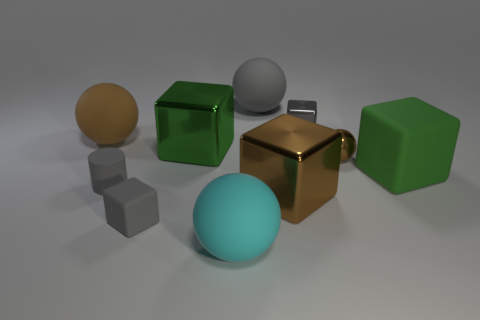The tiny matte object that is the same color as the rubber cylinder is what shape?
Make the answer very short. Cube. Does the small sphere have the same color as the cylinder?
Provide a succinct answer. No. What is the size of the cyan rubber object?
Keep it short and to the point. Large. There is a green object that is left of the large green block in front of the green metallic cube; how many tiny gray cylinders are to the right of it?
Give a very brief answer. 0. What is the shape of the big brown thing left of the big shiny block that is in front of the green metal thing?
Offer a very short reply. Sphere. What is the size of the gray thing that is the same shape as the tiny brown shiny object?
Provide a succinct answer. Large. Are there any other things that have the same size as the green rubber cube?
Ensure brevity in your answer.  Yes. What is the color of the metal block on the left side of the brown block?
Your answer should be compact. Green. The big green cube to the left of the large rubber ball behind the large thing to the left of the gray rubber block is made of what material?
Your answer should be very brief. Metal. There is a gray cube in front of the green cube that is on the left side of the tiny metallic cube; what size is it?
Provide a succinct answer. Small. 